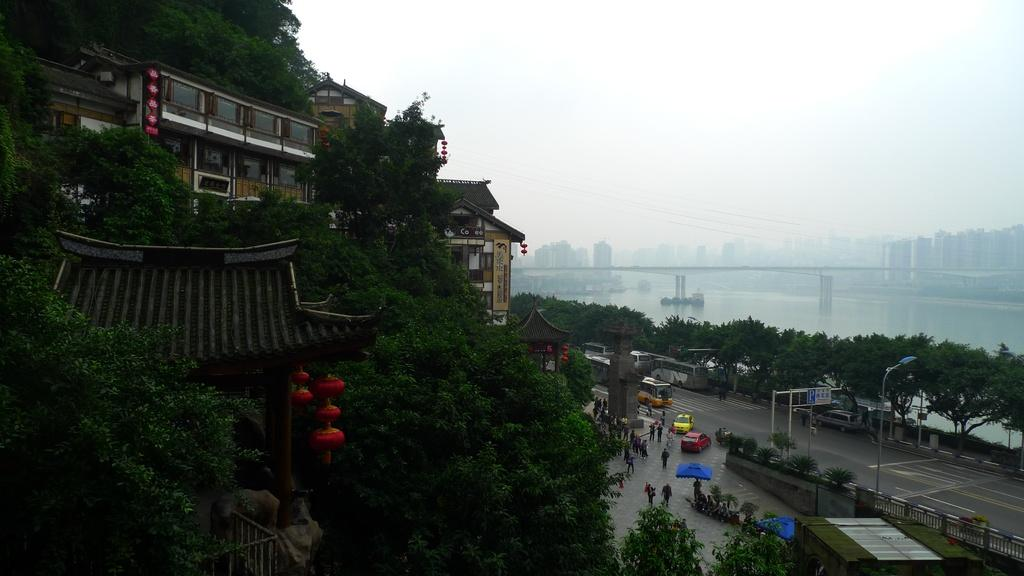What can be seen on the road in the image? There are vehicles and persons on the road in the image. What type of vegetation is present in the image? There are plants and trees in the image. What structures can be seen in the image? There are poles, boards, and buildings in the image. What else is visible in the image besides the road and structures? There is water visible in the image. What can be seen in the background of the image? The sky is visible in the background of the image. Where is the vase located in the image? There is no vase present in the image. What type of humor can be seen in the image? There is no humor depicted in the image; it is a scene of vehicles, persons, plants, trees, poles, boards, buildings, water, and the sky. 